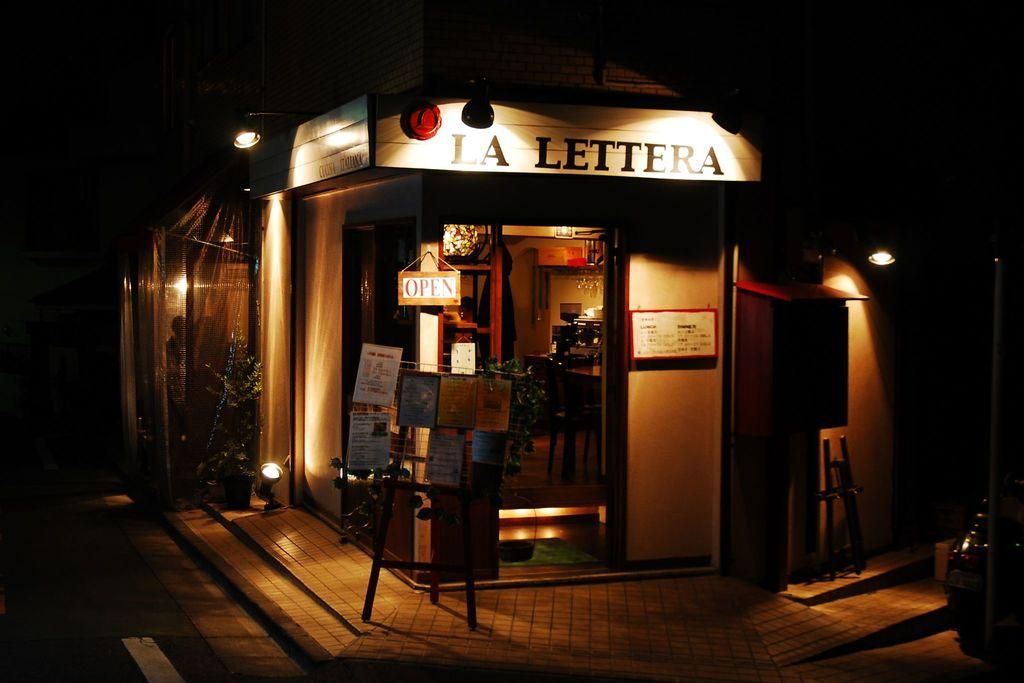<image>
Give a short and clear explanation of the subsequent image. Dark room with a tan door and LA LETTERA above it. 